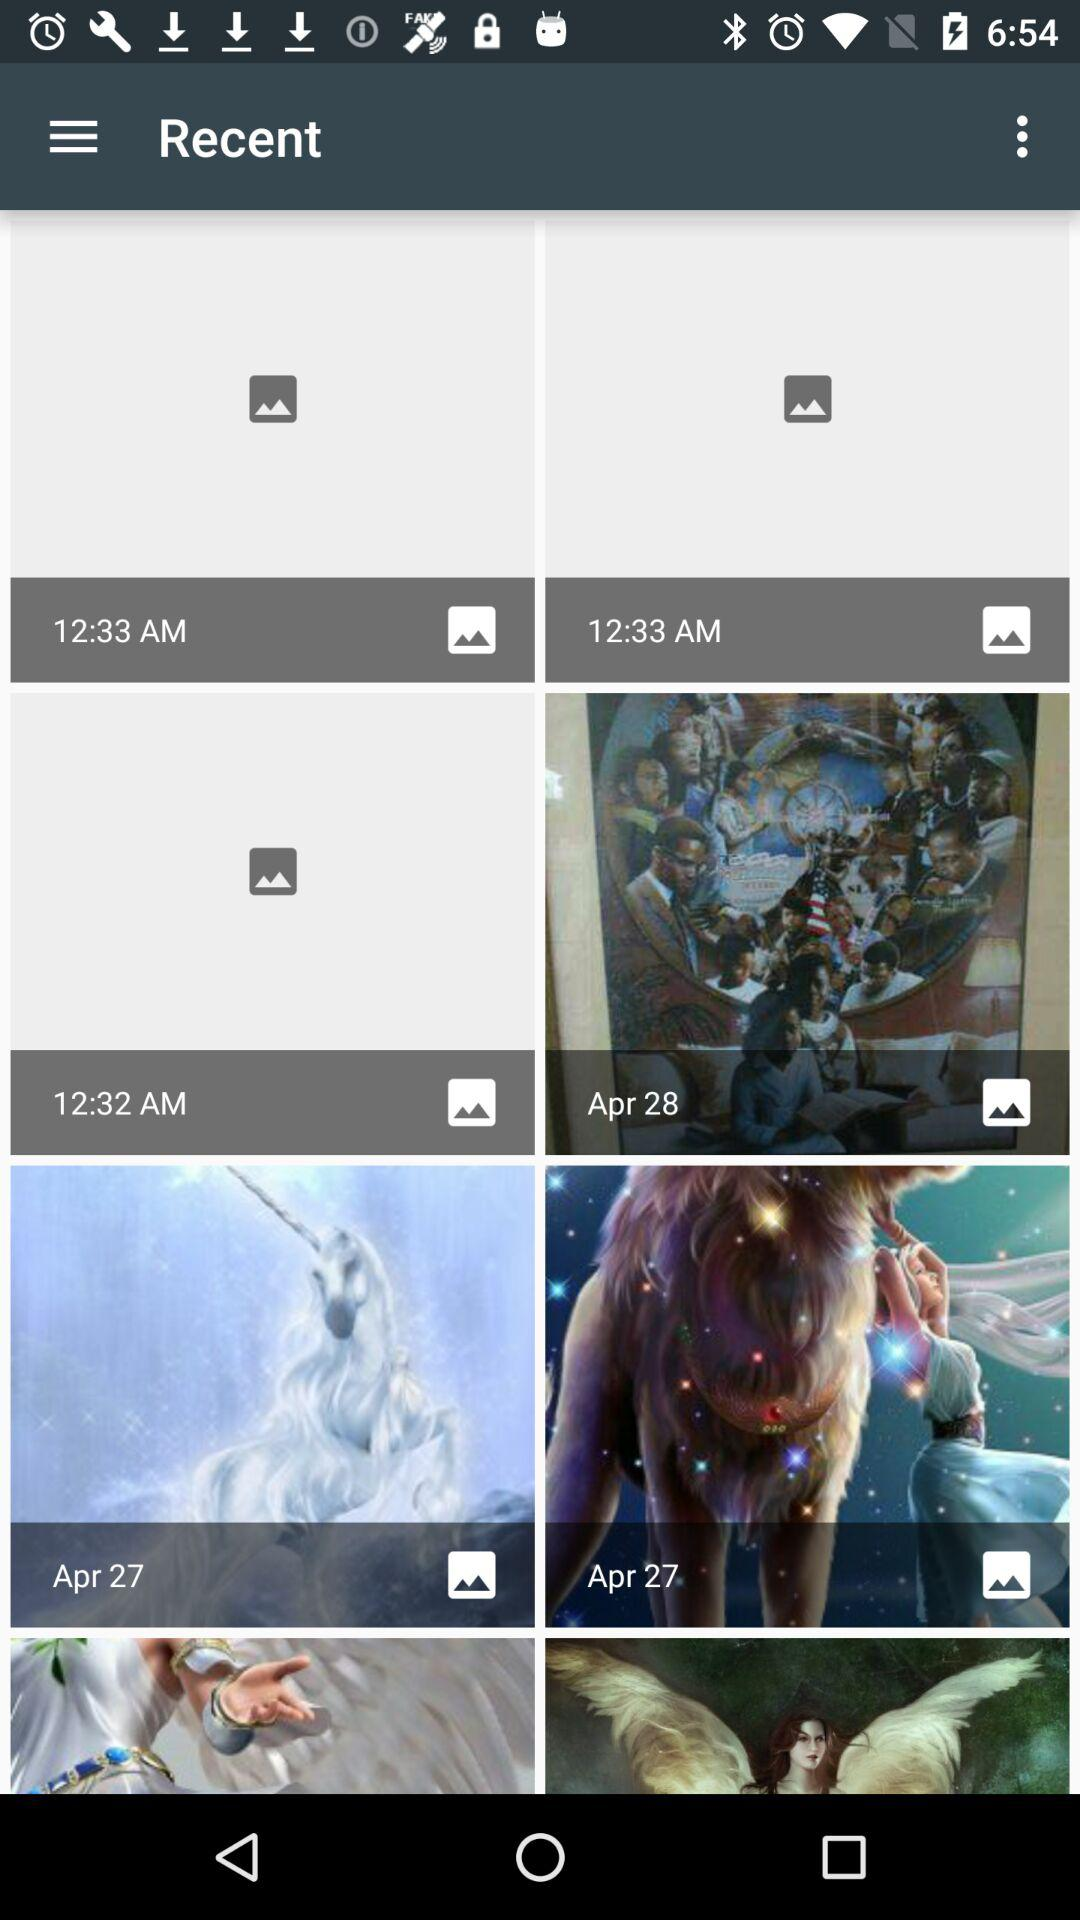How many pictures were taken on April 27th?
Answer the question using a single word or phrase. 2 